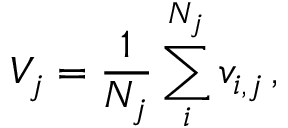<formula> <loc_0><loc_0><loc_500><loc_500>V _ { j } = \frac { 1 } { N _ { j } } \sum _ { i } ^ { N _ { j } } v _ { i , j } \, ,</formula> 